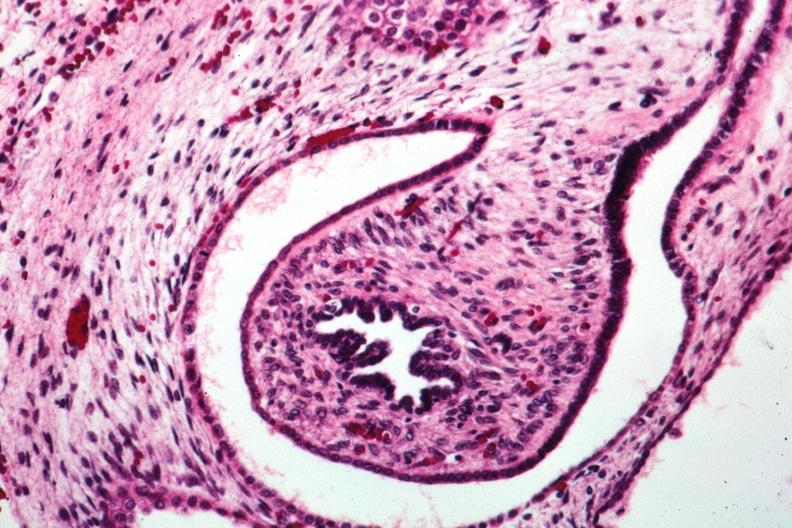where is this?
Answer the question using a single word or phrase. Urinary 